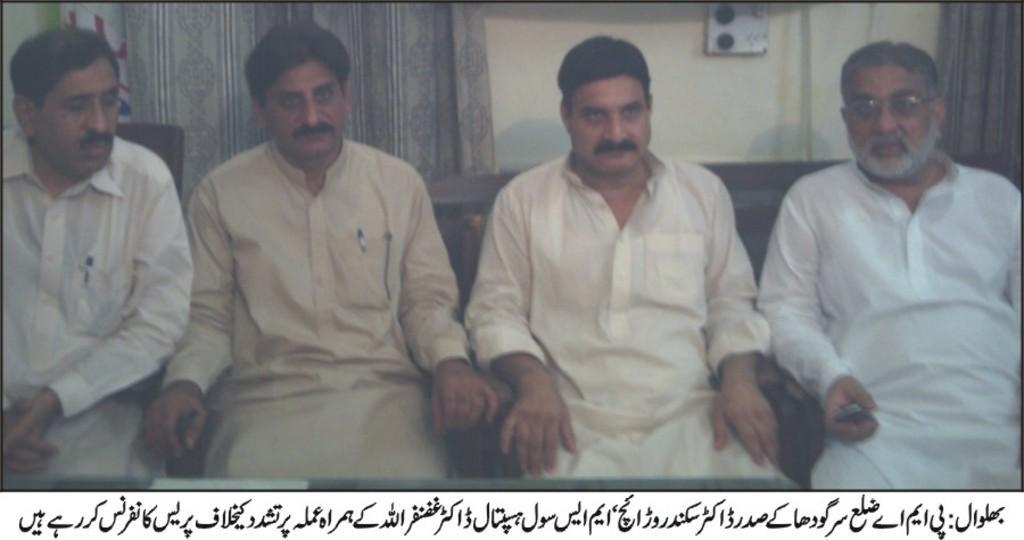Please provide a concise description of this image. In this image I can see four men are sitting and I can see all of them are wearing kurta. I can also see curtains and a switch board in the background. On the bottom side of this image I can see something is written. 